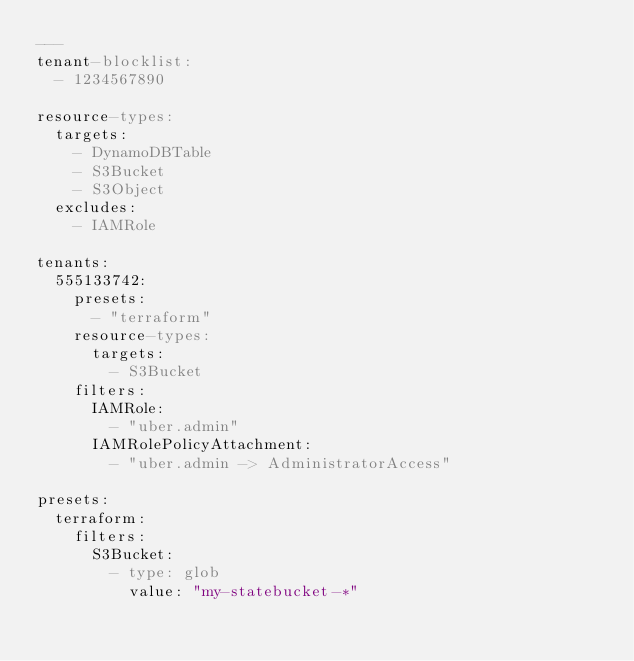<code> <loc_0><loc_0><loc_500><loc_500><_YAML_>---
tenant-blocklist:
  - 1234567890

resource-types:
  targets:
    - DynamoDBTable
    - S3Bucket
    - S3Object
  excludes:
    - IAMRole

tenants:
  555133742:
    presets:
      - "terraform"
    resource-types:
      targets:
        - S3Bucket
    filters:
      IAMRole:
        - "uber.admin"
      IAMRolePolicyAttachment:
        - "uber.admin -> AdministratorAccess"

presets:
  terraform:
    filters:
      S3Bucket:
        - type: glob
          value: "my-statebucket-*"
</code> 